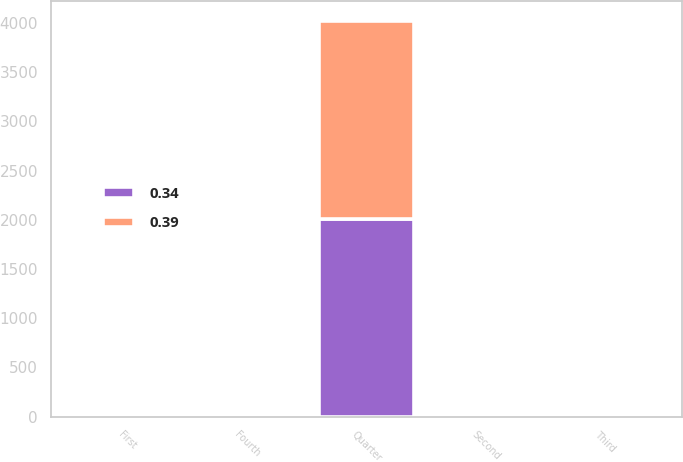Convert chart. <chart><loc_0><loc_0><loc_500><loc_500><stacked_bar_chart><ecel><fcel>Quarter<fcel>First<fcel>Second<fcel>Third<fcel>Fourth<nl><fcel>0.34<fcel>2013<fcel>0.34<fcel>0.34<fcel>0.39<fcel>0.39<nl><fcel>0.39<fcel>2012<fcel>0.31<fcel>0.31<fcel>0.34<fcel>0.34<nl></chart> 